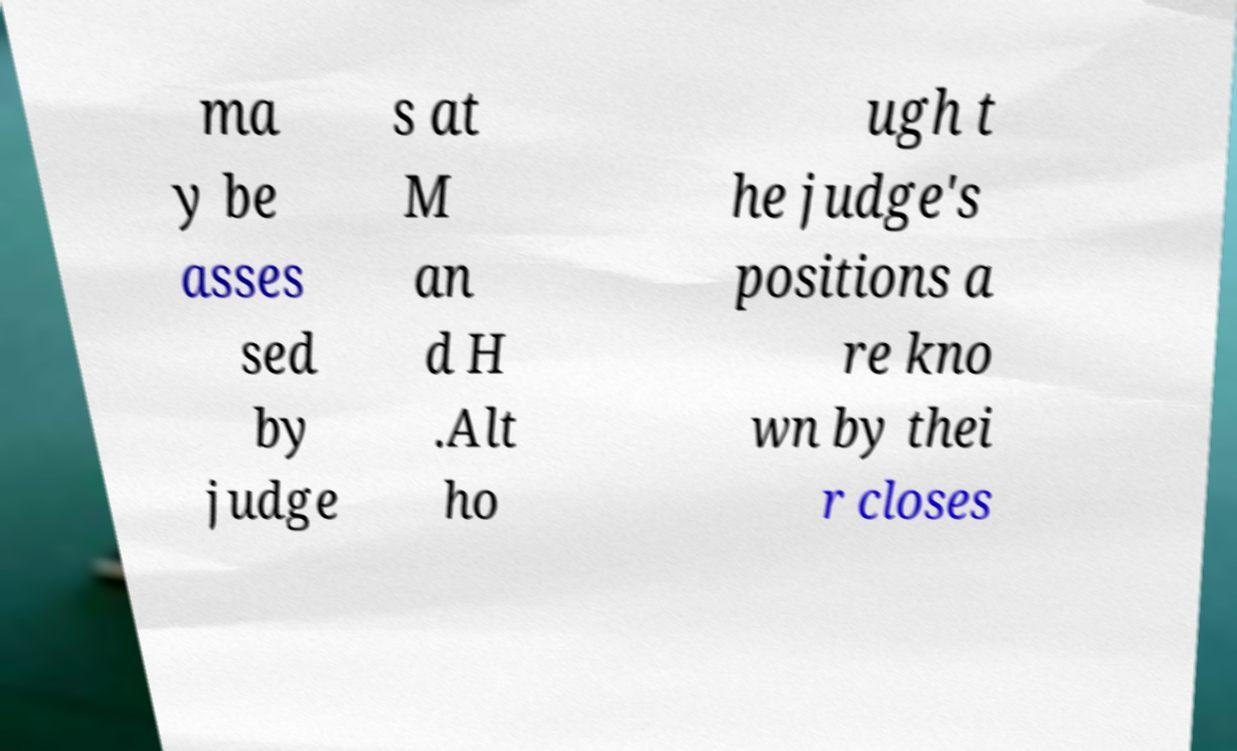Could you assist in decoding the text presented in this image and type it out clearly? ma y be asses sed by judge s at M an d H .Alt ho ugh t he judge's positions a re kno wn by thei r closes 